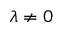Convert formula to latex. <formula><loc_0><loc_0><loc_500><loc_500>\lambda \ne 0</formula> 